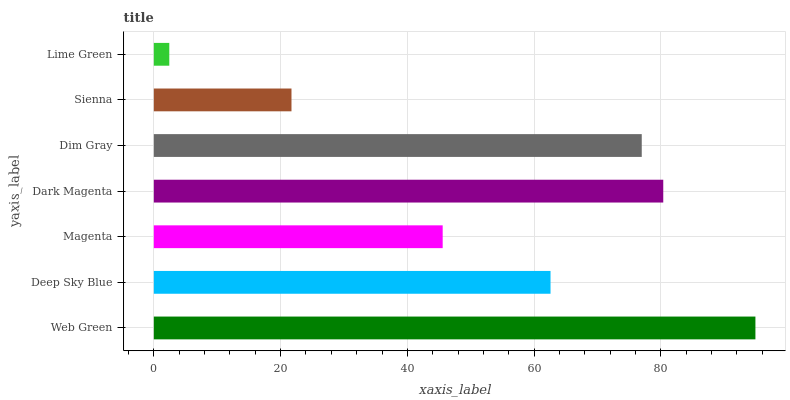Is Lime Green the minimum?
Answer yes or no. Yes. Is Web Green the maximum?
Answer yes or no. Yes. Is Deep Sky Blue the minimum?
Answer yes or no. No. Is Deep Sky Blue the maximum?
Answer yes or no. No. Is Web Green greater than Deep Sky Blue?
Answer yes or no. Yes. Is Deep Sky Blue less than Web Green?
Answer yes or no. Yes. Is Deep Sky Blue greater than Web Green?
Answer yes or no. No. Is Web Green less than Deep Sky Blue?
Answer yes or no. No. Is Deep Sky Blue the high median?
Answer yes or no. Yes. Is Deep Sky Blue the low median?
Answer yes or no. Yes. Is Lime Green the high median?
Answer yes or no. No. Is Magenta the low median?
Answer yes or no. No. 